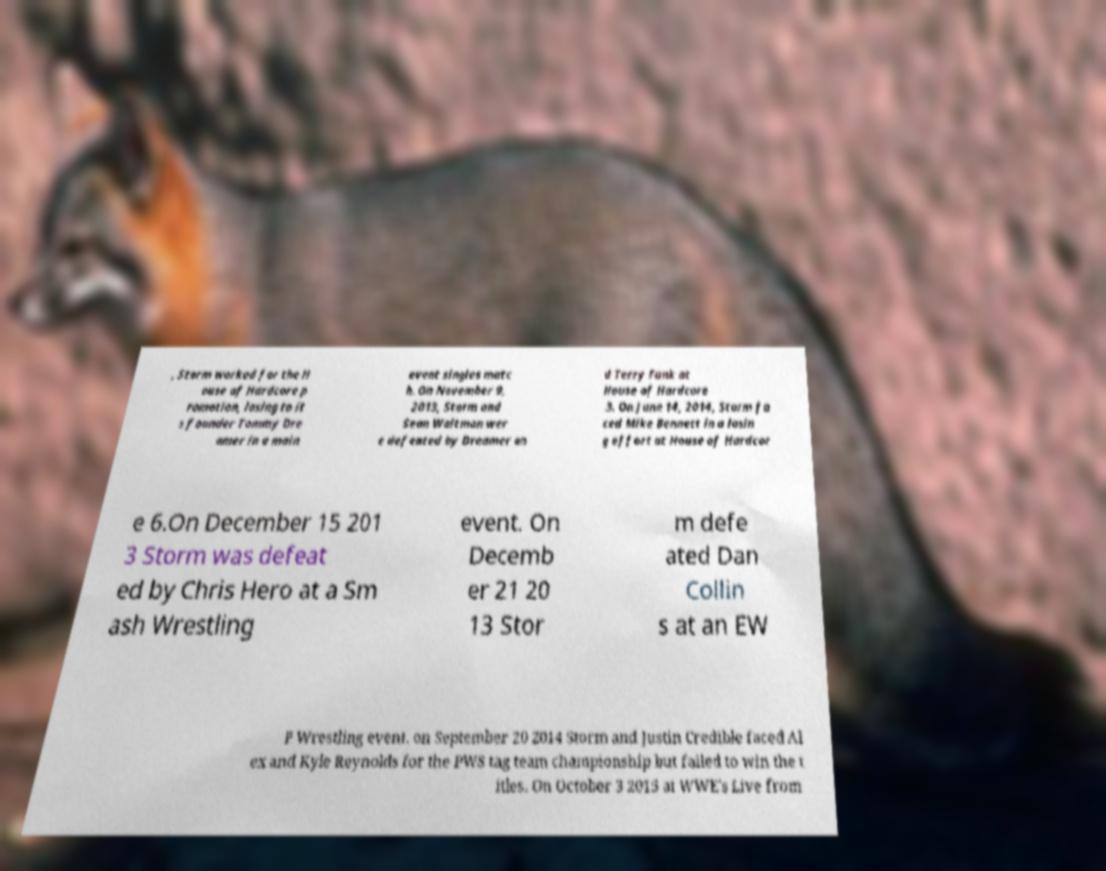I need the written content from this picture converted into text. Can you do that? , Storm worked for the H ouse of Hardcore p romotion, losing to it s founder Tommy Dre amer in a main event singles matc h. On November 9, 2013, Storm and Sean Waltman wer e defeated by Dreamer an d Terry Funk at House of Hardcore 3. On June 14, 2014, Storm fa ced Mike Bennett in a losin g effort at House of Hardcor e 6.On December 15 201 3 Storm was defeat ed by Chris Hero at a Sm ash Wrestling event. On Decemb er 21 20 13 Stor m defe ated Dan Collin s at an EW P Wrestling event. on September 20 2014 Storm and Justin Credible faced Al ex and Kyle Reynolds for the PWS tag team championship but failed to win the t itles. On October 3 2015 at WWE's Live from 